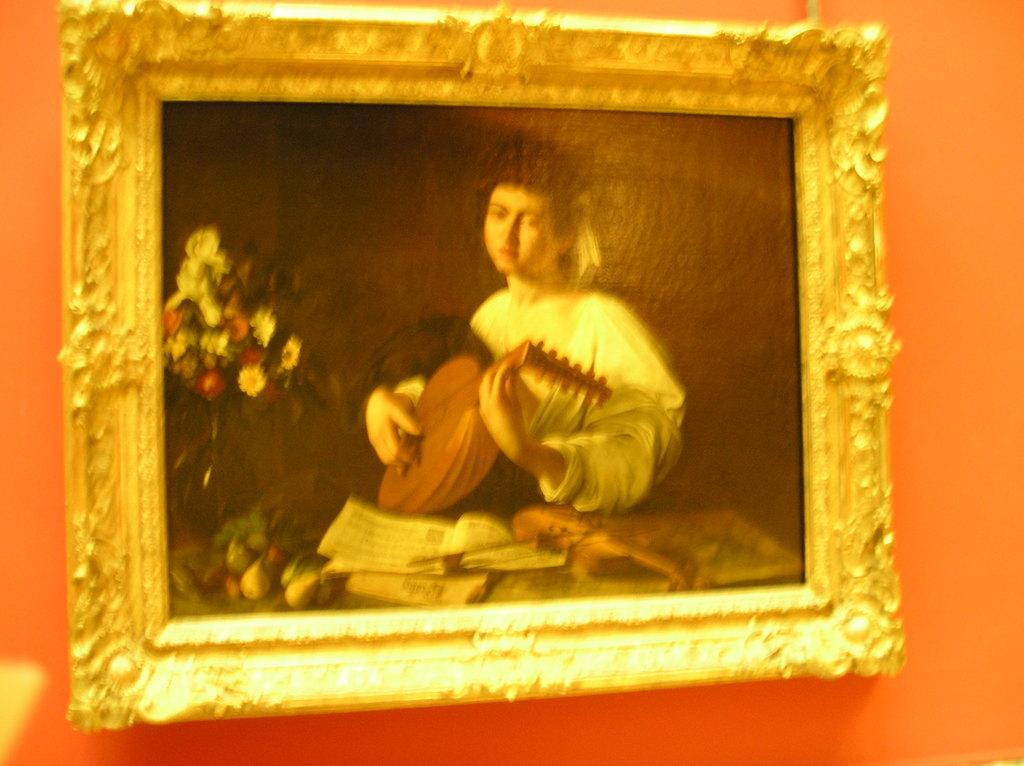What is the main subject of the painting in the image? There is a painting of a woman in the image. What is the woman holding in the painting? The woman is depicted with books in the painting. Are there any other objects in the painting besides the woman and books? Yes, there is a flower vase in the painting. What color is the wall on which the painting is hung? The painting is on an orange color wall. How many vegetables are present in the painting? There are no vegetables depicted in the painting; it features a woman with books and a flower vase. 